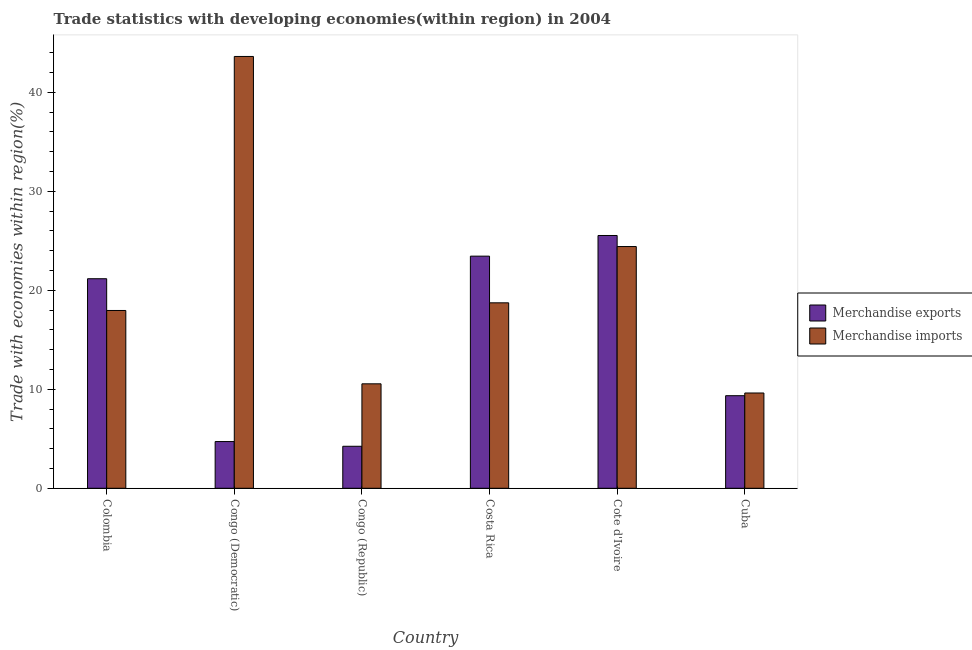How many different coloured bars are there?
Keep it short and to the point. 2. Are the number of bars per tick equal to the number of legend labels?
Provide a short and direct response. Yes. How many bars are there on the 4th tick from the left?
Provide a short and direct response. 2. What is the label of the 5th group of bars from the left?
Your answer should be compact. Cote d'Ivoire. What is the merchandise imports in Colombia?
Your response must be concise. 17.96. Across all countries, what is the maximum merchandise exports?
Make the answer very short. 25.54. Across all countries, what is the minimum merchandise exports?
Offer a very short reply. 4.24. In which country was the merchandise exports maximum?
Ensure brevity in your answer.  Cote d'Ivoire. In which country was the merchandise imports minimum?
Your answer should be very brief. Cuba. What is the total merchandise exports in the graph?
Your answer should be compact. 88.47. What is the difference between the merchandise exports in Congo (Democratic) and that in Congo (Republic)?
Provide a succinct answer. 0.48. What is the difference between the merchandise imports in Congo (Republic) and the merchandise exports in Costa Rica?
Make the answer very short. -12.9. What is the average merchandise exports per country?
Ensure brevity in your answer.  14.75. What is the difference between the merchandise exports and merchandise imports in Congo (Democratic)?
Give a very brief answer. -38.9. What is the ratio of the merchandise exports in Congo (Republic) to that in Cuba?
Keep it short and to the point. 0.45. Is the merchandise imports in Colombia less than that in Congo (Republic)?
Offer a terse response. No. What is the difference between the highest and the second highest merchandise exports?
Keep it short and to the point. 2.09. What is the difference between the highest and the lowest merchandise imports?
Ensure brevity in your answer.  34. In how many countries, is the merchandise exports greater than the average merchandise exports taken over all countries?
Your response must be concise. 3. How many bars are there?
Offer a terse response. 12. Are all the bars in the graph horizontal?
Your answer should be compact. No. How many countries are there in the graph?
Ensure brevity in your answer.  6. Are the values on the major ticks of Y-axis written in scientific E-notation?
Make the answer very short. No. Does the graph contain any zero values?
Offer a very short reply. No. Where does the legend appear in the graph?
Ensure brevity in your answer.  Center right. How many legend labels are there?
Your answer should be very brief. 2. How are the legend labels stacked?
Make the answer very short. Vertical. What is the title of the graph?
Keep it short and to the point. Trade statistics with developing economies(within region) in 2004. Does "Working only" appear as one of the legend labels in the graph?
Provide a short and direct response. No. What is the label or title of the X-axis?
Offer a very short reply. Country. What is the label or title of the Y-axis?
Your answer should be very brief. Trade with economies within region(%). What is the Trade with economies within region(%) of Merchandise exports in Colombia?
Your answer should be very brief. 21.17. What is the Trade with economies within region(%) of Merchandise imports in Colombia?
Your response must be concise. 17.96. What is the Trade with economies within region(%) in Merchandise exports in Congo (Democratic)?
Keep it short and to the point. 4.72. What is the Trade with economies within region(%) of Merchandise imports in Congo (Democratic)?
Keep it short and to the point. 43.62. What is the Trade with economies within region(%) of Merchandise exports in Congo (Republic)?
Ensure brevity in your answer.  4.24. What is the Trade with economies within region(%) in Merchandise imports in Congo (Republic)?
Provide a short and direct response. 10.55. What is the Trade with economies within region(%) in Merchandise exports in Costa Rica?
Your answer should be compact. 23.45. What is the Trade with economies within region(%) of Merchandise imports in Costa Rica?
Ensure brevity in your answer.  18.74. What is the Trade with economies within region(%) in Merchandise exports in Cote d'Ivoire?
Provide a succinct answer. 25.54. What is the Trade with economies within region(%) in Merchandise imports in Cote d'Ivoire?
Make the answer very short. 24.42. What is the Trade with economies within region(%) in Merchandise exports in Cuba?
Keep it short and to the point. 9.35. What is the Trade with economies within region(%) of Merchandise imports in Cuba?
Ensure brevity in your answer.  9.63. Across all countries, what is the maximum Trade with economies within region(%) of Merchandise exports?
Make the answer very short. 25.54. Across all countries, what is the maximum Trade with economies within region(%) in Merchandise imports?
Offer a very short reply. 43.62. Across all countries, what is the minimum Trade with economies within region(%) in Merchandise exports?
Keep it short and to the point. 4.24. Across all countries, what is the minimum Trade with economies within region(%) in Merchandise imports?
Your answer should be very brief. 9.63. What is the total Trade with economies within region(%) of Merchandise exports in the graph?
Your response must be concise. 88.47. What is the total Trade with economies within region(%) of Merchandise imports in the graph?
Your answer should be compact. 124.92. What is the difference between the Trade with economies within region(%) in Merchandise exports in Colombia and that in Congo (Democratic)?
Provide a short and direct response. 16.45. What is the difference between the Trade with economies within region(%) in Merchandise imports in Colombia and that in Congo (Democratic)?
Give a very brief answer. -25.66. What is the difference between the Trade with economies within region(%) of Merchandise exports in Colombia and that in Congo (Republic)?
Provide a succinct answer. 16.93. What is the difference between the Trade with economies within region(%) of Merchandise imports in Colombia and that in Congo (Republic)?
Make the answer very short. 7.41. What is the difference between the Trade with economies within region(%) in Merchandise exports in Colombia and that in Costa Rica?
Provide a short and direct response. -2.28. What is the difference between the Trade with economies within region(%) in Merchandise imports in Colombia and that in Costa Rica?
Keep it short and to the point. -0.77. What is the difference between the Trade with economies within region(%) in Merchandise exports in Colombia and that in Cote d'Ivoire?
Give a very brief answer. -4.37. What is the difference between the Trade with economies within region(%) in Merchandise imports in Colombia and that in Cote d'Ivoire?
Your response must be concise. -6.46. What is the difference between the Trade with economies within region(%) of Merchandise exports in Colombia and that in Cuba?
Offer a terse response. 11.82. What is the difference between the Trade with economies within region(%) in Merchandise imports in Colombia and that in Cuba?
Offer a very short reply. 8.34. What is the difference between the Trade with economies within region(%) of Merchandise exports in Congo (Democratic) and that in Congo (Republic)?
Keep it short and to the point. 0.48. What is the difference between the Trade with economies within region(%) of Merchandise imports in Congo (Democratic) and that in Congo (Republic)?
Keep it short and to the point. 33.07. What is the difference between the Trade with economies within region(%) in Merchandise exports in Congo (Democratic) and that in Costa Rica?
Your response must be concise. -18.73. What is the difference between the Trade with economies within region(%) of Merchandise imports in Congo (Democratic) and that in Costa Rica?
Your response must be concise. 24.89. What is the difference between the Trade with economies within region(%) in Merchandise exports in Congo (Democratic) and that in Cote d'Ivoire?
Your response must be concise. -20.82. What is the difference between the Trade with economies within region(%) of Merchandise imports in Congo (Democratic) and that in Cote d'Ivoire?
Provide a succinct answer. 19.2. What is the difference between the Trade with economies within region(%) in Merchandise exports in Congo (Democratic) and that in Cuba?
Ensure brevity in your answer.  -4.63. What is the difference between the Trade with economies within region(%) in Merchandise imports in Congo (Democratic) and that in Cuba?
Your answer should be compact. 34. What is the difference between the Trade with economies within region(%) in Merchandise exports in Congo (Republic) and that in Costa Rica?
Offer a terse response. -19.21. What is the difference between the Trade with economies within region(%) of Merchandise imports in Congo (Republic) and that in Costa Rica?
Give a very brief answer. -8.18. What is the difference between the Trade with economies within region(%) in Merchandise exports in Congo (Republic) and that in Cote d'Ivoire?
Give a very brief answer. -21.29. What is the difference between the Trade with economies within region(%) of Merchandise imports in Congo (Republic) and that in Cote d'Ivoire?
Ensure brevity in your answer.  -13.87. What is the difference between the Trade with economies within region(%) of Merchandise exports in Congo (Republic) and that in Cuba?
Make the answer very short. -5.11. What is the difference between the Trade with economies within region(%) of Merchandise imports in Congo (Republic) and that in Cuba?
Offer a very short reply. 0.93. What is the difference between the Trade with economies within region(%) in Merchandise exports in Costa Rica and that in Cote d'Ivoire?
Offer a very short reply. -2.09. What is the difference between the Trade with economies within region(%) in Merchandise imports in Costa Rica and that in Cote d'Ivoire?
Ensure brevity in your answer.  -5.69. What is the difference between the Trade with economies within region(%) in Merchandise exports in Costa Rica and that in Cuba?
Offer a terse response. 14.1. What is the difference between the Trade with economies within region(%) of Merchandise imports in Costa Rica and that in Cuba?
Offer a very short reply. 9.11. What is the difference between the Trade with economies within region(%) of Merchandise exports in Cote d'Ivoire and that in Cuba?
Keep it short and to the point. 16.18. What is the difference between the Trade with economies within region(%) in Merchandise imports in Cote d'Ivoire and that in Cuba?
Your response must be concise. 14.8. What is the difference between the Trade with economies within region(%) in Merchandise exports in Colombia and the Trade with economies within region(%) in Merchandise imports in Congo (Democratic)?
Make the answer very short. -22.45. What is the difference between the Trade with economies within region(%) of Merchandise exports in Colombia and the Trade with economies within region(%) of Merchandise imports in Congo (Republic)?
Give a very brief answer. 10.62. What is the difference between the Trade with economies within region(%) in Merchandise exports in Colombia and the Trade with economies within region(%) in Merchandise imports in Costa Rica?
Ensure brevity in your answer.  2.43. What is the difference between the Trade with economies within region(%) of Merchandise exports in Colombia and the Trade with economies within region(%) of Merchandise imports in Cote d'Ivoire?
Your answer should be compact. -3.25. What is the difference between the Trade with economies within region(%) of Merchandise exports in Colombia and the Trade with economies within region(%) of Merchandise imports in Cuba?
Offer a very short reply. 11.54. What is the difference between the Trade with economies within region(%) of Merchandise exports in Congo (Democratic) and the Trade with economies within region(%) of Merchandise imports in Congo (Republic)?
Your answer should be compact. -5.83. What is the difference between the Trade with economies within region(%) of Merchandise exports in Congo (Democratic) and the Trade with economies within region(%) of Merchandise imports in Costa Rica?
Your answer should be compact. -14.02. What is the difference between the Trade with economies within region(%) in Merchandise exports in Congo (Democratic) and the Trade with economies within region(%) in Merchandise imports in Cote d'Ivoire?
Provide a short and direct response. -19.7. What is the difference between the Trade with economies within region(%) of Merchandise exports in Congo (Democratic) and the Trade with economies within region(%) of Merchandise imports in Cuba?
Your response must be concise. -4.91. What is the difference between the Trade with economies within region(%) in Merchandise exports in Congo (Republic) and the Trade with economies within region(%) in Merchandise imports in Costa Rica?
Offer a very short reply. -14.49. What is the difference between the Trade with economies within region(%) of Merchandise exports in Congo (Republic) and the Trade with economies within region(%) of Merchandise imports in Cote d'Ivoire?
Make the answer very short. -20.18. What is the difference between the Trade with economies within region(%) of Merchandise exports in Congo (Republic) and the Trade with economies within region(%) of Merchandise imports in Cuba?
Give a very brief answer. -5.38. What is the difference between the Trade with economies within region(%) of Merchandise exports in Costa Rica and the Trade with economies within region(%) of Merchandise imports in Cote d'Ivoire?
Offer a terse response. -0.97. What is the difference between the Trade with economies within region(%) of Merchandise exports in Costa Rica and the Trade with economies within region(%) of Merchandise imports in Cuba?
Ensure brevity in your answer.  13.82. What is the difference between the Trade with economies within region(%) in Merchandise exports in Cote d'Ivoire and the Trade with economies within region(%) in Merchandise imports in Cuba?
Offer a terse response. 15.91. What is the average Trade with economies within region(%) in Merchandise exports per country?
Keep it short and to the point. 14.75. What is the average Trade with economies within region(%) in Merchandise imports per country?
Give a very brief answer. 20.82. What is the difference between the Trade with economies within region(%) of Merchandise exports and Trade with economies within region(%) of Merchandise imports in Colombia?
Provide a short and direct response. 3.21. What is the difference between the Trade with economies within region(%) of Merchandise exports and Trade with economies within region(%) of Merchandise imports in Congo (Democratic)?
Your answer should be very brief. -38.9. What is the difference between the Trade with economies within region(%) of Merchandise exports and Trade with economies within region(%) of Merchandise imports in Congo (Republic)?
Offer a very short reply. -6.31. What is the difference between the Trade with economies within region(%) of Merchandise exports and Trade with economies within region(%) of Merchandise imports in Costa Rica?
Keep it short and to the point. 4.72. What is the difference between the Trade with economies within region(%) in Merchandise exports and Trade with economies within region(%) in Merchandise imports in Cote d'Ivoire?
Your answer should be compact. 1.12. What is the difference between the Trade with economies within region(%) in Merchandise exports and Trade with economies within region(%) in Merchandise imports in Cuba?
Provide a short and direct response. -0.27. What is the ratio of the Trade with economies within region(%) of Merchandise exports in Colombia to that in Congo (Democratic)?
Provide a short and direct response. 4.48. What is the ratio of the Trade with economies within region(%) in Merchandise imports in Colombia to that in Congo (Democratic)?
Your answer should be compact. 0.41. What is the ratio of the Trade with economies within region(%) of Merchandise exports in Colombia to that in Congo (Republic)?
Provide a succinct answer. 4.99. What is the ratio of the Trade with economies within region(%) of Merchandise imports in Colombia to that in Congo (Republic)?
Your answer should be compact. 1.7. What is the ratio of the Trade with economies within region(%) of Merchandise exports in Colombia to that in Costa Rica?
Ensure brevity in your answer.  0.9. What is the ratio of the Trade with economies within region(%) of Merchandise imports in Colombia to that in Costa Rica?
Provide a short and direct response. 0.96. What is the ratio of the Trade with economies within region(%) of Merchandise exports in Colombia to that in Cote d'Ivoire?
Offer a very short reply. 0.83. What is the ratio of the Trade with economies within region(%) in Merchandise imports in Colombia to that in Cote d'Ivoire?
Offer a terse response. 0.74. What is the ratio of the Trade with economies within region(%) in Merchandise exports in Colombia to that in Cuba?
Your response must be concise. 2.26. What is the ratio of the Trade with economies within region(%) of Merchandise imports in Colombia to that in Cuba?
Offer a very short reply. 1.87. What is the ratio of the Trade with economies within region(%) of Merchandise exports in Congo (Democratic) to that in Congo (Republic)?
Your answer should be very brief. 1.11. What is the ratio of the Trade with economies within region(%) of Merchandise imports in Congo (Democratic) to that in Congo (Republic)?
Keep it short and to the point. 4.13. What is the ratio of the Trade with economies within region(%) in Merchandise exports in Congo (Democratic) to that in Costa Rica?
Give a very brief answer. 0.2. What is the ratio of the Trade with economies within region(%) in Merchandise imports in Congo (Democratic) to that in Costa Rica?
Provide a succinct answer. 2.33. What is the ratio of the Trade with economies within region(%) of Merchandise exports in Congo (Democratic) to that in Cote d'Ivoire?
Give a very brief answer. 0.18. What is the ratio of the Trade with economies within region(%) in Merchandise imports in Congo (Democratic) to that in Cote d'Ivoire?
Offer a very short reply. 1.79. What is the ratio of the Trade with economies within region(%) in Merchandise exports in Congo (Democratic) to that in Cuba?
Keep it short and to the point. 0.5. What is the ratio of the Trade with economies within region(%) of Merchandise imports in Congo (Democratic) to that in Cuba?
Your response must be concise. 4.53. What is the ratio of the Trade with economies within region(%) in Merchandise exports in Congo (Republic) to that in Costa Rica?
Ensure brevity in your answer.  0.18. What is the ratio of the Trade with economies within region(%) of Merchandise imports in Congo (Republic) to that in Costa Rica?
Provide a short and direct response. 0.56. What is the ratio of the Trade with economies within region(%) in Merchandise exports in Congo (Republic) to that in Cote d'Ivoire?
Provide a short and direct response. 0.17. What is the ratio of the Trade with economies within region(%) in Merchandise imports in Congo (Republic) to that in Cote d'Ivoire?
Make the answer very short. 0.43. What is the ratio of the Trade with economies within region(%) in Merchandise exports in Congo (Republic) to that in Cuba?
Make the answer very short. 0.45. What is the ratio of the Trade with economies within region(%) in Merchandise imports in Congo (Republic) to that in Cuba?
Your response must be concise. 1.1. What is the ratio of the Trade with economies within region(%) of Merchandise exports in Costa Rica to that in Cote d'Ivoire?
Give a very brief answer. 0.92. What is the ratio of the Trade with economies within region(%) of Merchandise imports in Costa Rica to that in Cote d'Ivoire?
Offer a very short reply. 0.77. What is the ratio of the Trade with economies within region(%) of Merchandise exports in Costa Rica to that in Cuba?
Your answer should be compact. 2.51. What is the ratio of the Trade with economies within region(%) in Merchandise imports in Costa Rica to that in Cuba?
Your response must be concise. 1.95. What is the ratio of the Trade with economies within region(%) of Merchandise exports in Cote d'Ivoire to that in Cuba?
Your answer should be compact. 2.73. What is the ratio of the Trade with economies within region(%) of Merchandise imports in Cote d'Ivoire to that in Cuba?
Provide a short and direct response. 2.54. What is the difference between the highest and the second highest Trade with economies within region(%) in Merchandise exports?
Offer a very short reply. 2.09. What is the difference between the highest and the second highest Trade with economies within region(%) in Merchandise imports?
Provide a short and direct response. 19.2. What is the difference between the highest and the lowest Trade with economies within region(%) in Merchandise exports?
Offer a terse response. 21.29. What is the difference between the highest and the lowest Trade with economies within region(%) of Merchandise imports?
Provide a succinct answer. 34. 